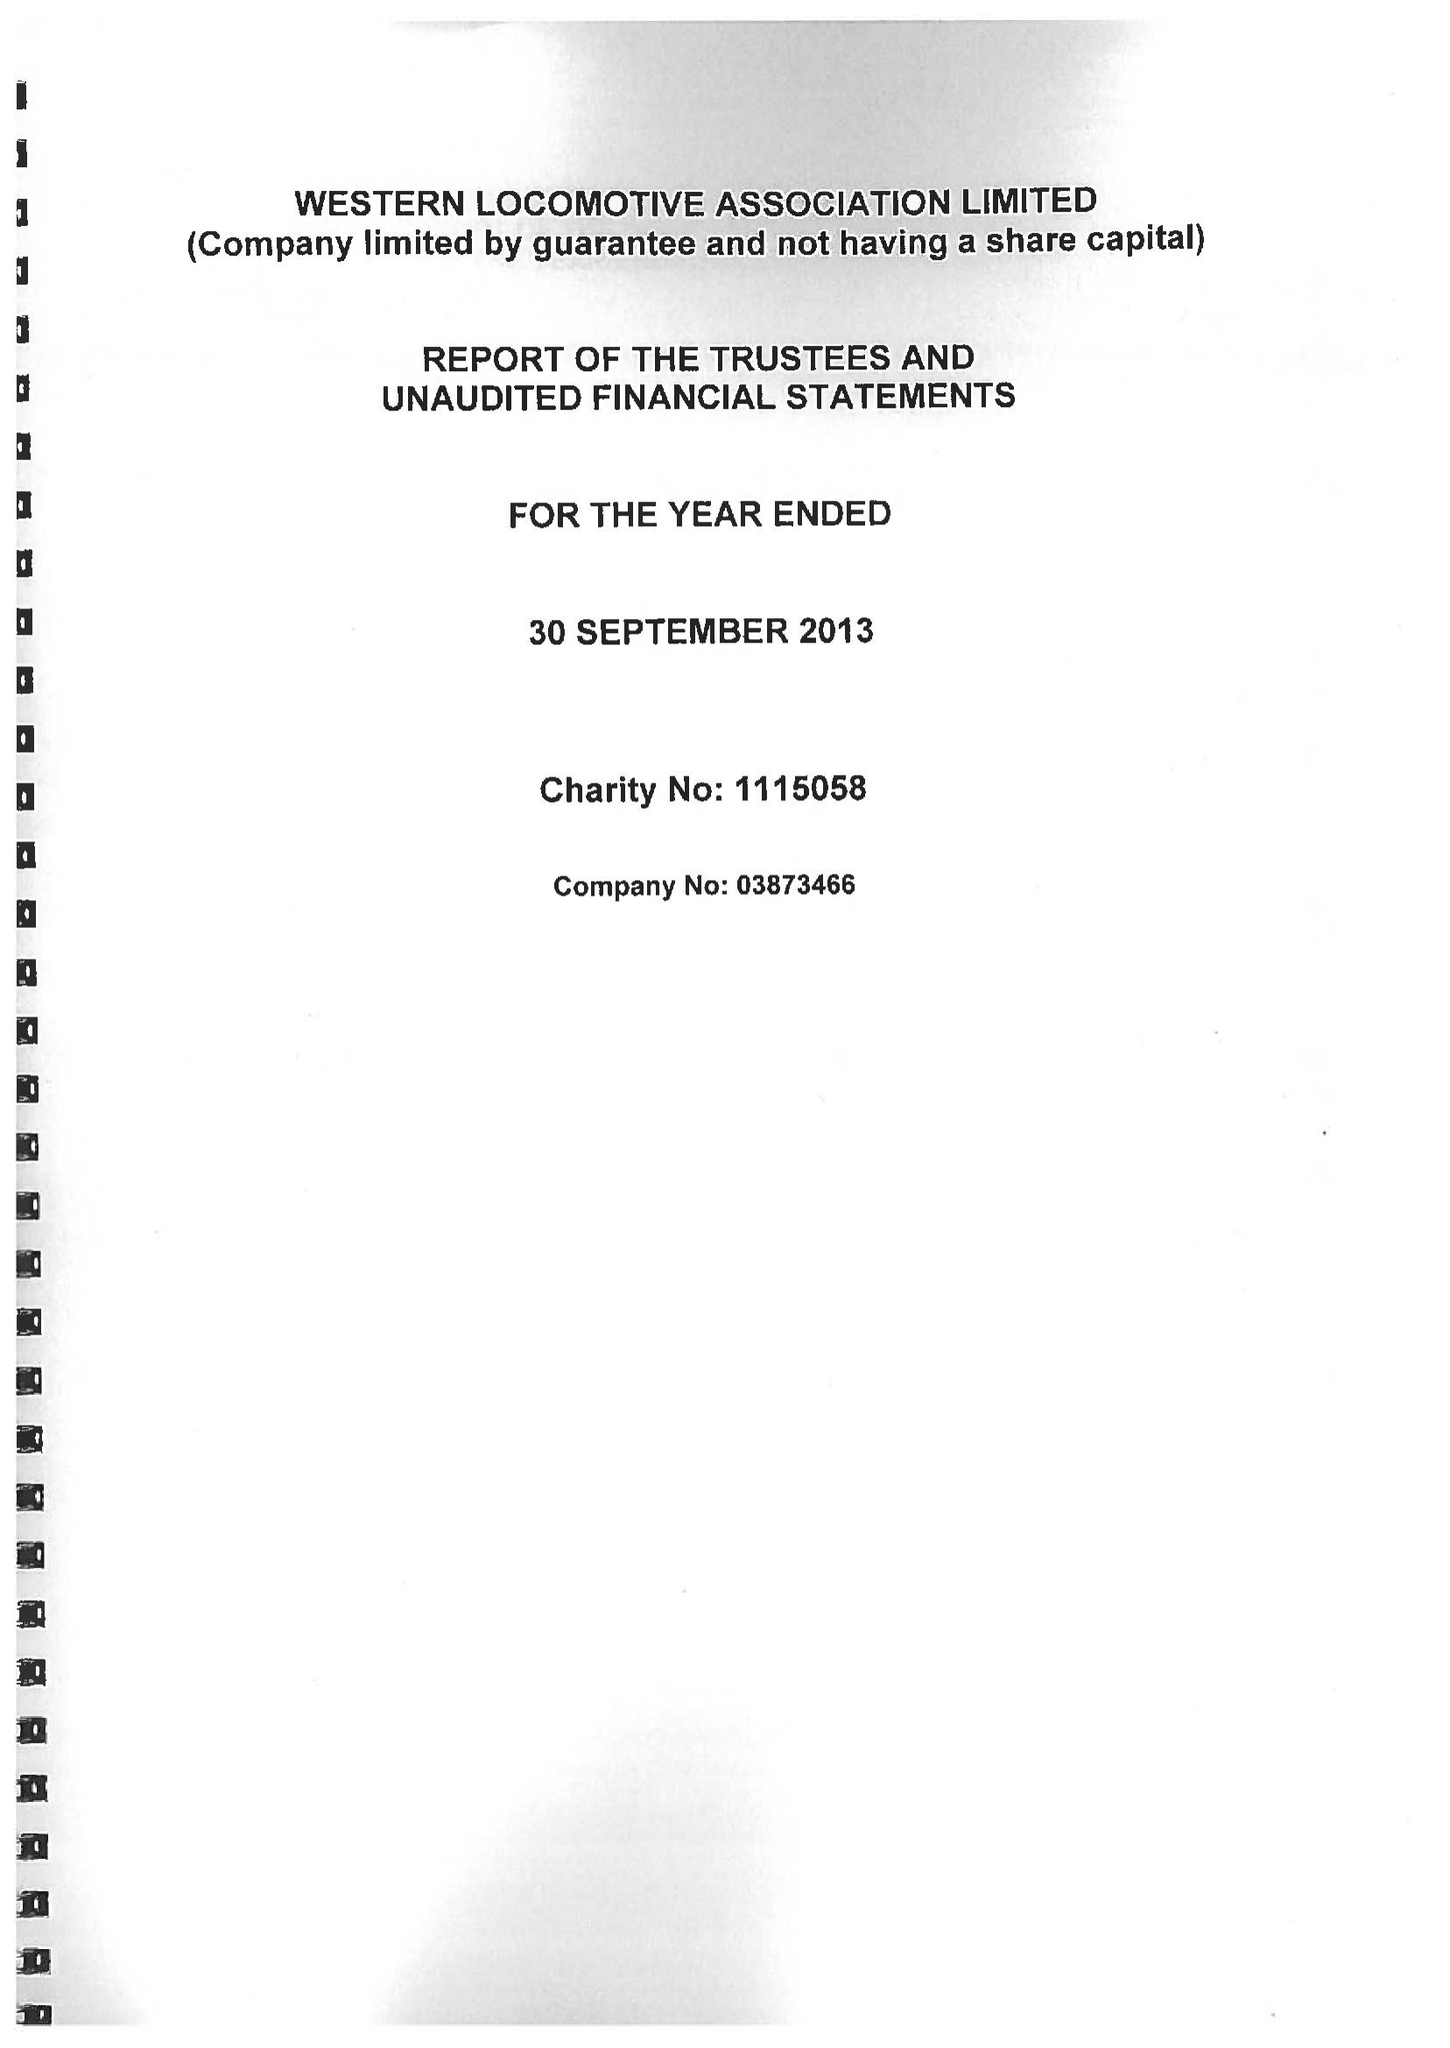What is the value for the charity_name?
Answer the question using a single word or phrase. Western Locomotive Association Ltd. 